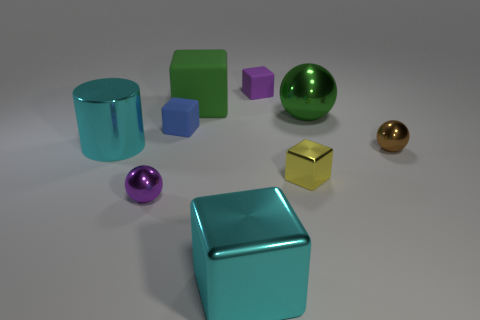What number of other things are made of the same material as the small blue thing?
Your response must be concise. 2. Is the tiny cube that is behind the large green metallic sphere made of the same material as the big green block?
Provide a succinct answer. Yes. What is the shape of the big green rubber thing?
Offer a terse response. Cube. Is the number of blue blocks that are in front of the big rubber cube greater than the number of big cyan rubber cylinders?
Provide a short and direct response. Yes. Is there any other thing that has the same shape as the small purple rubber object?
Your response must be concise. Yes. There is another tiny metallic thing that is the same shape as the blue thing; what is its color?
Offer a terse response. Yellow. The large cyan metallic thing right of the cyan shiny cylinder has what shape?
Offer a terse response. Cube. There is a purple shiny ball; are there any tiny yellow metal things behind it?
Your response must be concise. Yes. What is the color of the big ball that is made of the same material as the tiny brown ball?
Your response must be concise. Green. There is a tiny rubber cube that is in front of the green cube; is its color the same as the big object that is left of the green rubber object?
Your answer should be compact. No. 